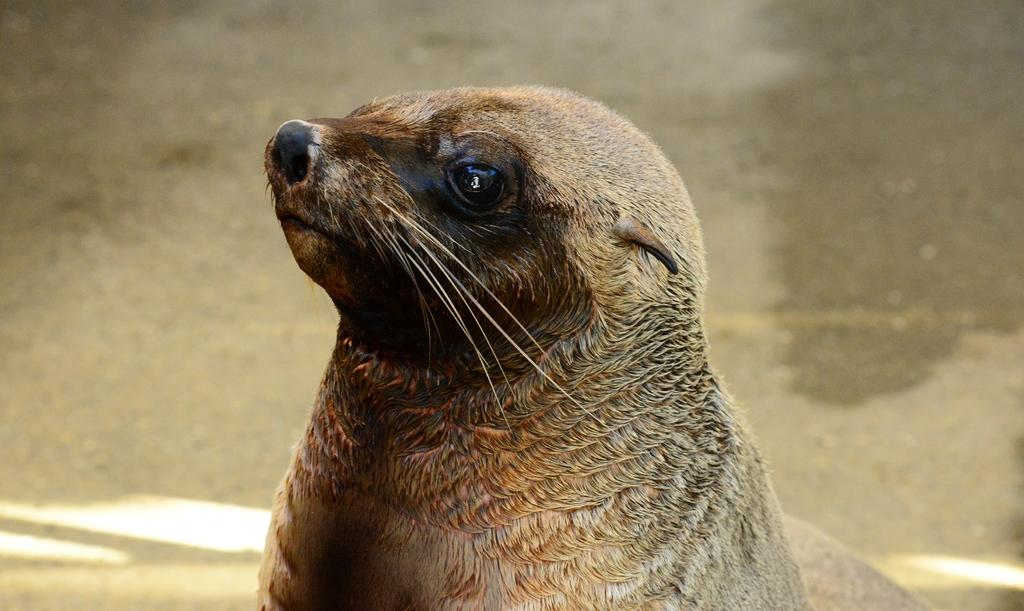What type of animal can be seen in the image? There is a grey and black color animal in the image. What type of stamp can be seen on the animal's forehead in the image? There is no stamp visible on the animal's forehead in the image. Where is the downtown area in relation to the animal in the image? The image does not show any downtown area, nor does it provide any information about the animal's location. 